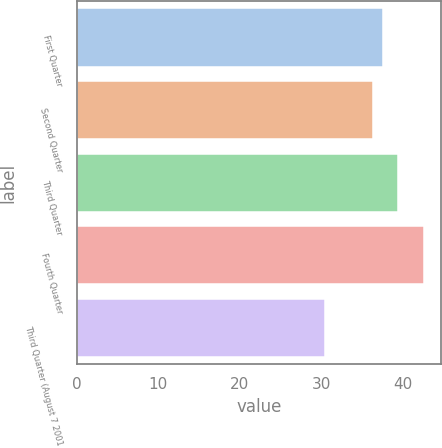Convert chart to OTSL. <chart><loc_0><loc_0><loc_500><loc_500><bar_chart><fcel>First Quarter<fcel>Second Quarter<fcel>Third Quarter<fcel>Fourth Quarter<fcel>Third Quarter (August 7 2001<nl><fcel>37.55<fcel>36.34<fcel>39.46<fcel>42.6<fcel>30.5<nl></chart> 